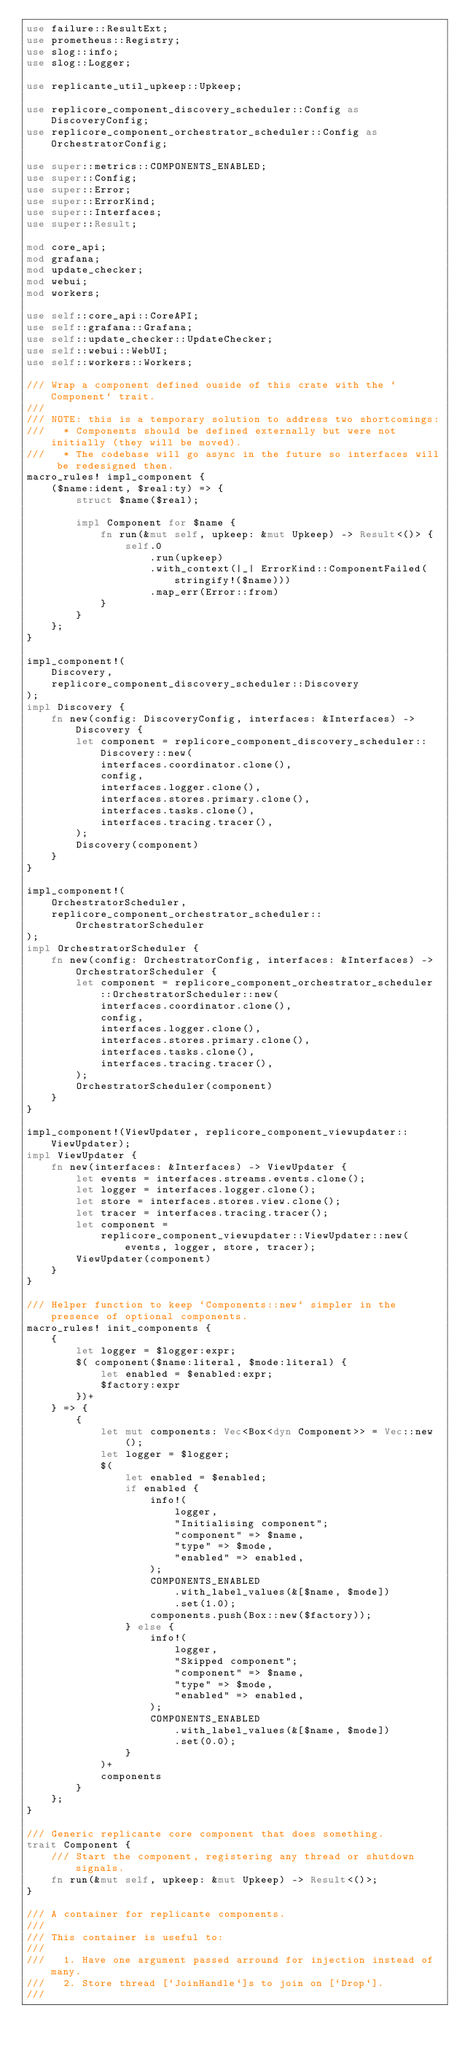Convert code to text. <code><loc_0><loc_0><loc_500><loc_500><_Rust_>use failure::ResultExt;
use prometheus::Registry;
use slog::info;
use slog::Logger;

use replicante_util_upkeep::Upkeep;

use replicore_component_discovery_scheduler::Config as DiscoveryConfig;
use replicore_component_orchestrator_scheduler::Config as OrchestratorConfig;

use super::metrics::COMPONENTS_ENABLED;
use super::Config;
use super::Error;
use super::ErrorKind;
use super::Interfaces;
use super::Result;

mod core_api;
mod grafana;
mod update_checker;
mod webui;
mod workers;

use self::core_api::CoreAPI;
use self::grafana::Grafana;
use self::update_checker::UpdateChecker;
use self::webui::WebUI;
use self::workers::Workers;

/// Wrap a component defined ouside of this crate with the `Component` trait.
///
/// NOTE: this is a temporary solution to address two shortcomings:
///   * Components should be defined externally but were not initially (they will be moved).
///   * The codebase will go async in the future so interfaces will be redesigned then.
macro_rules! impl_component {
    ($name:ident, $real:ty) => {
        struct $name($real);

        impl Component for $name {
            fn run(&mut self, upkeep: &mut Upkeep) -> Result<()> {
                self.0
                    .run(upkeep)
                    .with_context(|_| ErrorKind::ComponentFailed(stringify!($name)))
                    .map_err(Error::from)
            }
        }
    };
}

impl_component!(
    Discovery,
    replicore_component_discovery_scheduler::Discovery
);
impl Discovery {
    fn new(config: DiscoveryConfig, interfaces: &Interfaces) -> Discovery {
        let component = replicore_component_discovery_scheduler::Discovery::new(
            interfaces.coordinator.clone(),
            config,
            interfaces.logger.clone(),
            interfaces.stores.primary.clone(),
            interfaces.tasks.clone(),
            interfaces.tracing.tracer(),
        );
        Discovery(component)
    }
}

impl_component!(
    OrchestratorScheduler,
    replicore_component_orchestrator_scheduler::OrchestratorScheduler
);
impl OrchestratorScheduler {
    fn new(config: OrchestratorConfig, interfaces: &Interfaces) -> OrchestratorScheduler {
        let component = replicore_component_orchestrator_scheduler::OrchestratorScheduler::new(
            interfaces.coordinator.clone(),
            config,
            interfaces.logger.clone(),
            interfaces.stores.primary.clone(),
            interfaces.tasks.clone(),
            interfaces.tracing.tracer(),
        );
        OrchestratorScheduler(component)
    }
}

impl_component!(ViewUpdater, replicore_component_viewupdater::ViewUpdater);
impl ViewUpdater {
    fn new(interfaces: &Interfaces) -> ViewUpdater {
        let events = interfaces.streams.events.clone();
        let logger = interfaces.logger.clone();
        let store = interfaces.stores.view.clone();
        let tracer = interfaces.tracing.tracer();
        let component =
            replicore_component_viewupdater::ViewUpdater::new(events, logger, store, tracer);
        ViewUpdater(component)
    }
}

/// Helper function to keep `Components::new` simpler in the presence of optional components.
macro_rules! init_components {
    {
        let logger = $logger:expr;
        $( component($name:literal, $mode:literal) {
            let enabled = $enabled:expr;
            $factory:expr
        })+
    } => {
        {
            let mut components: Vec<Box<dyn Component>> = Vec::new();
            let logger = $logger;
            $(
                let enabled = $enabled;
                if enabled {
                    info!(
                        logger,
                        "Initialising component";
                        "component" => $name,
                        "type" => $mode,
                        "enabled" => enabled,
                    );
                    COMPONENTS_ENABLED
                        .with_label_values(&[$name, $mode])
                        .set(1.0);
                    components.push(Box::new($factory));
                } else {
                    info!(
                        logger,
                        "Skipped component";
                        "component" => $name,
                        "type" => $mode,
                        "enabled" => enabled,
                    );
                    COMPONENTS_ENABLED
                        .with_label_values(&[$name, $mode])
                        .set(0.0);
                }
            )+
            components
        }
    };
}

/// Generic replicante core component that does something.
trait Component {
    /// Start the component, registering any thread or shutdown signals.
    fn run(&mut self, upkeep: &mut Upkeep) -> Result<()>;
}

/// A container for replicante components.
///
/// This container is useful to:
///
///   1. Have one argument passed arround for injection instead of many.
///   2. Store thread [`JoinHandle`]s to join on [`Drop`].
///</code> 